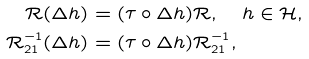<formula> <loc_0><loc_0><loc_500><loc_500>\mathcal { R } ( \Delta h ) & = ( \tau \circ \Delta h ) \mathcal { R } , \quad h \in \mathcal { H } , \\ \mathcal { R } _ { 2 1 } ^ { - 1 } ( \Delta h ) & = ( \tau \circ \Delta h ) \mathcal { R } _ { 2 1 } ^ { - 1 } ,</formula> 